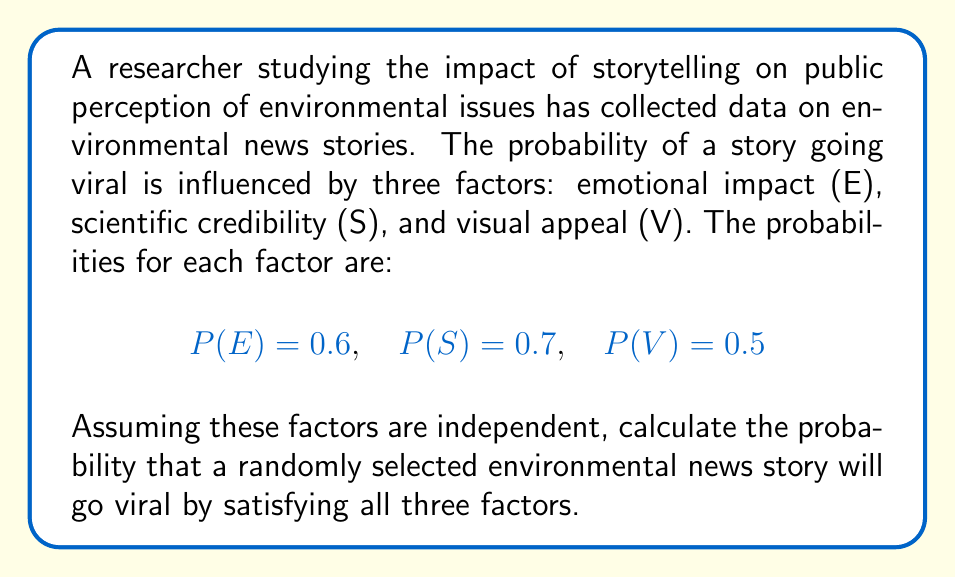Could you help me with this problem? To solve this problem, we need to follow these steps:

1. Understand the given probabilities:
   P(E) = 0.6 (probability of emotional impact)
   P(S) = 0.7 (probability of scientific credibility)
   P(V) = 0.5 (probability of visual appeal)

2. Recognize that we need to calculate the probability of all three events occurring simultaneously.

3. Since the factors are independent, we can use the multiplication rule of probability:
   
   P(E ∩ S ∩ V) = P(E) × P(S) × P(V)

4. Substitute the given probabilities into the formula:

   P(E ∩ S ∩ V) = 0.6 × 0.7 × 0.5

5. Calculate the result:

   P(E ∩ S ∩ V) = 0.21

Therefore, the probability that a randomly selected environmental news story will go viral by satisfying all three factors is 0.21 or 21%.
Answer: 0.21 